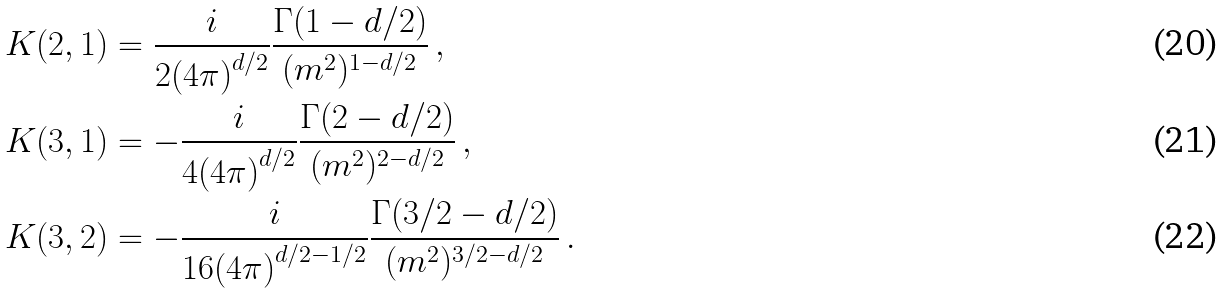Convert formula to latex. <formula><loc_0><loc_0><loc_500><loc_500>K ( 2 , 1 ) & = \frac { i } { 2 { ( 4 \pi ) } ^ { d / 2 } } \frac { \Gamma ( 1 - d / 2 ) } { ( m ^ { 2 } ) ^ { 1 - d / 2 } } \, , \\ K ( 3 , 1 ) & = - \frac { i } { 4 { ( 4 \pi ) } ^ { d / 2 } } \frac { \Gamma ( 2 - d / 2 ) } { ( m ^ { 2 } ) ^ { 2 - d / 2 } } \, , \\ K ( 3 , 2 ) & = - \frac { i } { 1 6 { ( 4 \pi ) } ^ { d / 2 - 1 / 2 } } \frac { \Gamma ( 3 / 2 - d / 2 ) } { ( m ^ { 2 } ) ^ { 3 / 2 - d / 2 } } \, .</formula> 